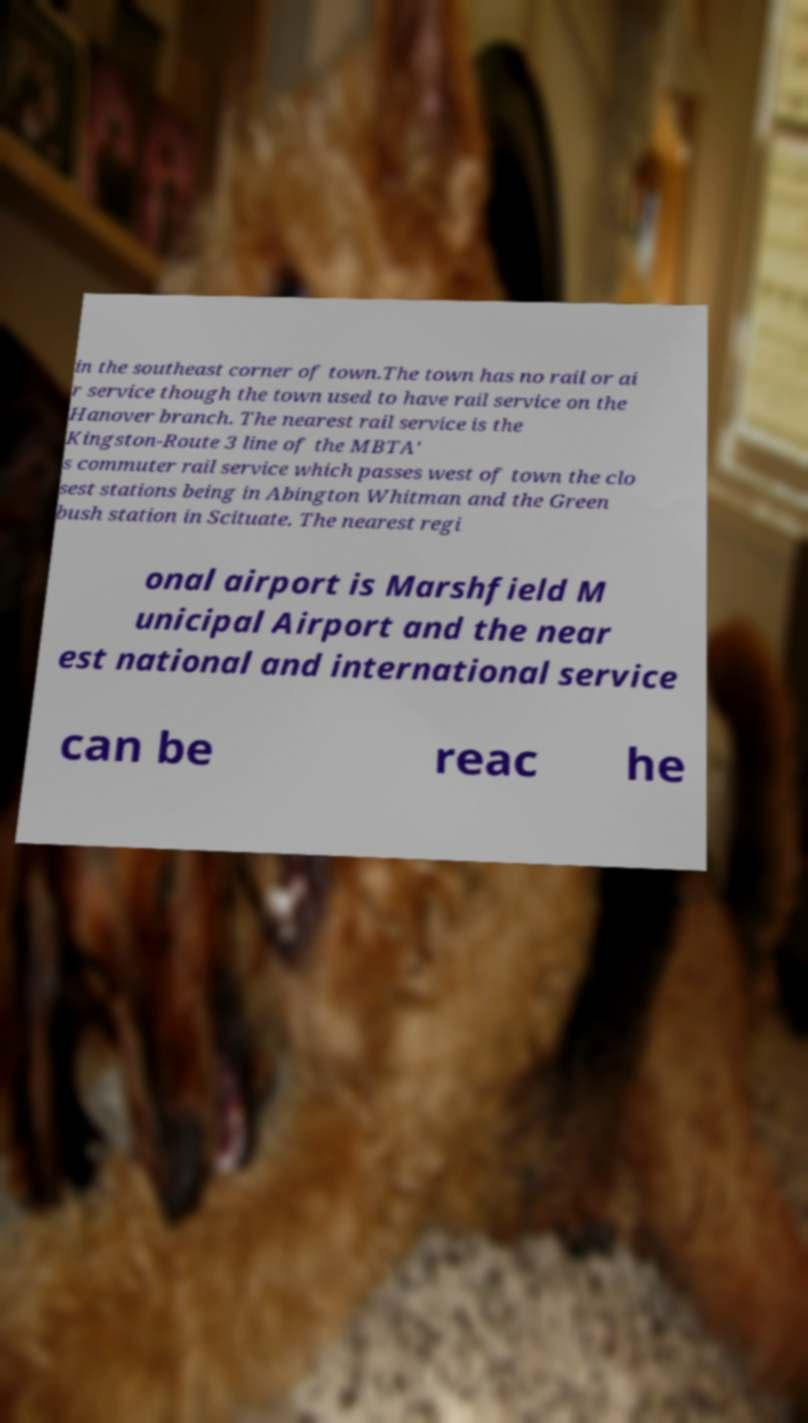For documentation purposes, I need the text within this image transcribed. Could you provide that? in the southeast corner of town.The town has no rail or ai r service though the town used to have rail service on the Hanover branch. The nearest rail service is the Kingston-Route 3 line of the MBTA' s commuter rail service which passes west of town the clo sest stations being in Abington Whitman and the Green bush station in Scituate. The nearest regi onal airport is Marshfield M unicipal Airport and the near est national and international service can be reac he 